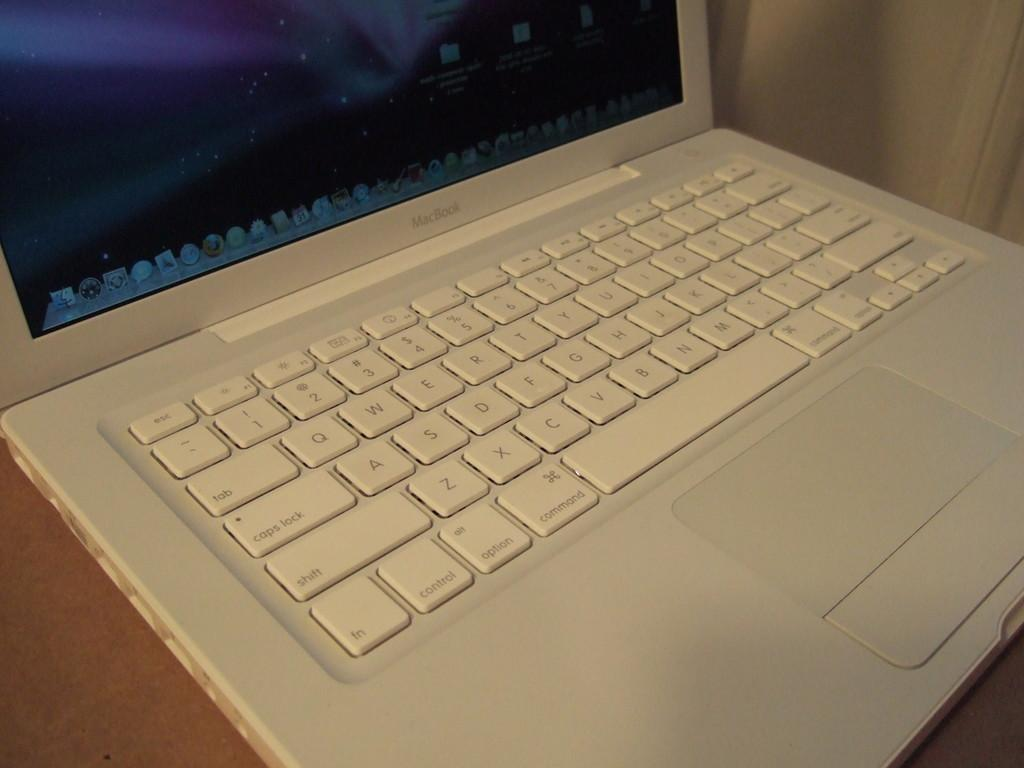<image>
Render a clear and concise summary of the photo. White macbook with white keyboard on top of a wooden table. 